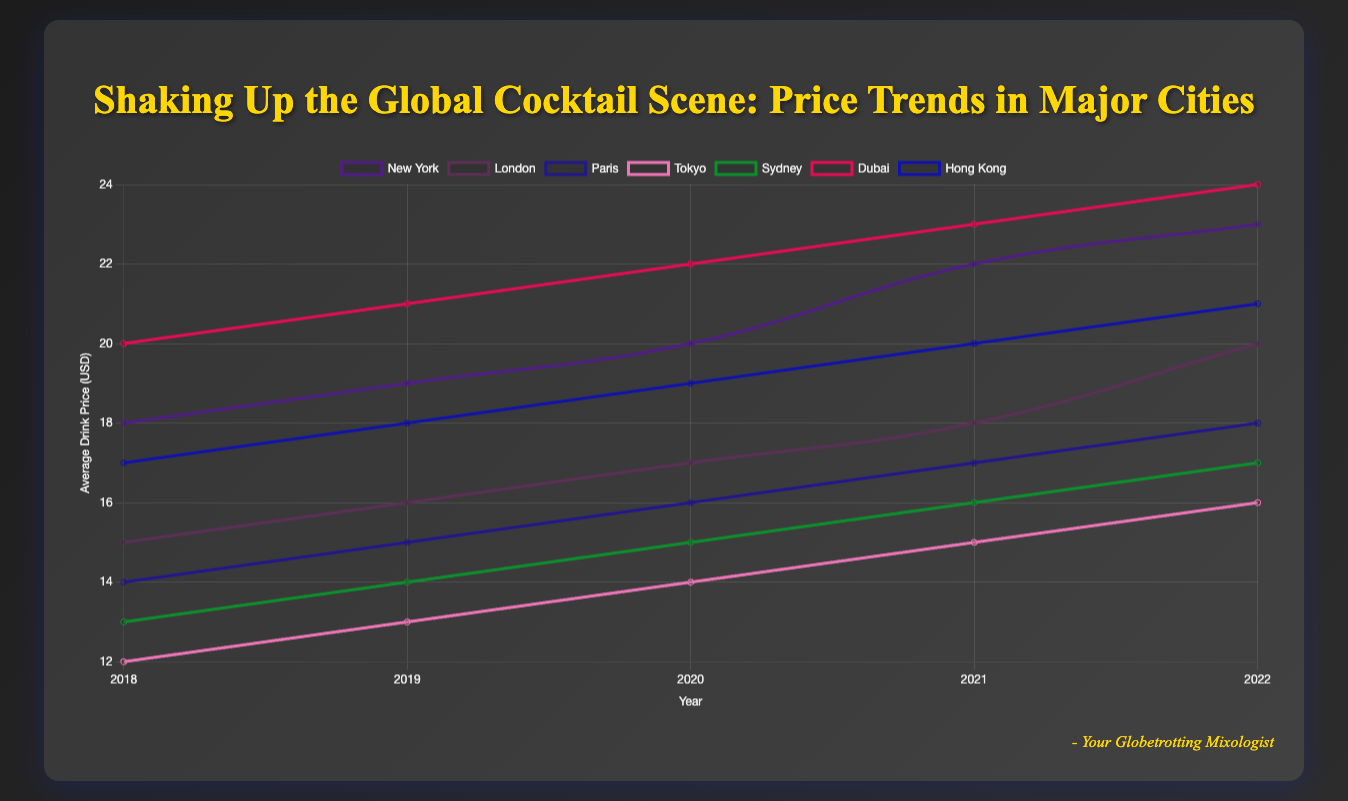What city had the highest average drink price in 2022? Look at the chart lines for 2022. Identify which city corresponds to the highest point.
Answer: Dubai Between 2018 and 2022, which city saw the largest absolute increase in average drink price? Calculate the difference between 2018 and 2022 prices for each city: 
- New York: 23 - 18 = 5 
- London: 20 - 15 = 5 
- Paris: 18 - 14 = 4 
- Tokyo: 16 - 12 = 4 
- Sydney: 17 - 13 = 4 
- Dubai: 24 - 20 = 4 
- Hong Kong: 21 - 17 = 4
- Compare the differences, New York and London both saw a $5 increase, which are the highest.
Answer: New York and London How does the average drink price in New York in 2022 compare to that in Paris in 2022? Check the 2022 values: New York is $23, Paris is $18. New York's price is higher than Paris's.
Answer: New York's price is higher Which year did London overtook Tokyo in average drink prices? Track each city's line until they cross. London overtook Tokyo between 2018 and 2019.
Answer: 2019 By how much did the average drink price in Hong Kong increase from 2018 to 2022? Subtract the 2018 price from the 2022 price for Hong Kong: 21 - 17.
Answer: $4 What is the average drink price in Sydney in 2021? Identify Sydney's line and read the value for 2021.
Answer: $16 Compare the trend lines for Tokyo and Paris. Which one shows a steeper increase in prices over the years? Calculate the slope for both cities:
- Paris: (18-14) / 4 = 1 
- Tokyo: (16-12) / 4 = 1
- Both cities have the same slope, indicating equal increase in prices over time.
Answer: Equal increase Which city had a more consistent year-over-year increase in drink prices, New York or Dubai? Look at the step sizes year by year for each city. 
- New York: 18 to 19, 19 to 20, 20 to 22, 22 to 23 
- Dubai: 20 to 21, 21 to 22, 22 to 23, 23 to 24 
- Both cities have a fairly consistent increase, but Dubai's increases are more uniform annually.
Answer: Dubai If you combine the average drink prices of New York and Hong Kong in 2019, what is the total? Add the values for 2019 from both cities: New York ($19) + Hong Kong ($18) = $37
Answer: $37 